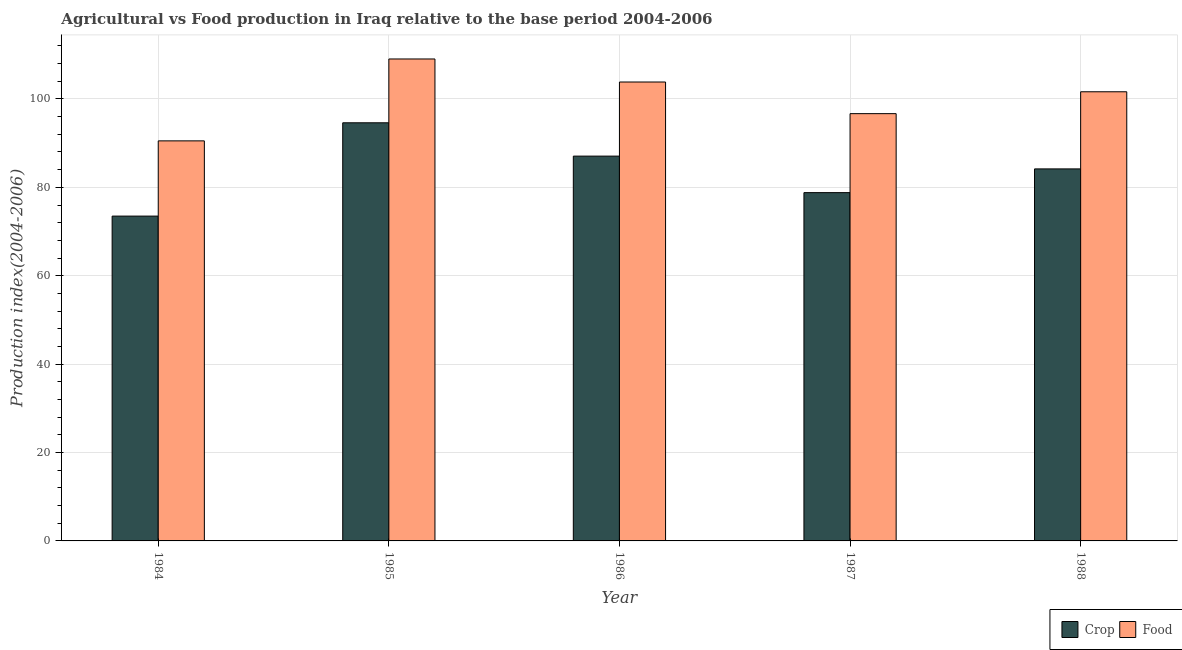How many different coloured bars are there?
Give a very brief answer. 2. How many bars are there on the 1st tick from the left?
Offer a terse response. 2. How many bars are there on the 3rd tick from the right?
Provide a succinct answer. 2. What is the label of the 3rd group of bars from the left?
Your response must be concise. 1986. In how many cases, is the number of bars for a given year not equal to the number of legend labels?
Give a very brief answer. 0. What is the food production index in 1985?
Make the answer very short. 109.04. Across all years, what is the maximum food production index?
Make the answer very short. 109.04. Across all years, what is the minimum food production index?
Make the answer very short. 90.51. In which year was the crop production index maximum?
Give a very brief answer. 1985. In which year was the food production index minimum?
Provide a succinct answer. 1984. What is the total food production index in the graph?
Provide a short and direct response. 501.67. What is the difference between the crop production index in 1984 and that in 1985?
Offer a terse response. -21.11. What is the difference between the crop production index in 1988 and the food production index in 1984?
Keep it short and to the point. 10.68. What is the average food production index per year?
Give a very brief answer. 100.33. In how many years, is the crop production index greater than 56?
Keep it short and to the point. 5. What is the ratio of the food production index in 1987 to that in 1988?
Offer a terse response. 0.95. Is the difference between the crop production index in 1985 and 1986 greater than the difference between the food production index in 1985 and 1986?
Your response must be concise. No. What is the difference between the highest and the second highest food production index?
Make the answer very short. 5.21. What is the difference between the highest and the lowest crop production index?
Offer a very short reply. 21.11. Is the sum of the food production index in 1986 and 1987 greater than the maximum crop production index across all years?
Give a very brief answer. Yes. What does the 2nd bar from the left in 1986 represents?
Give a very brief answer. Food. What does the 2nd bar from the right in 1984 represents?
Give a very brief answer. Crop. Are all the bars in the graph horizontal?
Your response must be concise. No. How many years are there in the graph?
Provide a succinct answer. 5. Does the graph contain grids?
Make the answer very short. Yes. How many legend labels are there?
Offer a terse response. 2. What is the title of the graph?
Offer a terse response. Agricultural vs Food production in Iraq relative to the base period 2004-2006. What is the label or title of the X-axis?
Your response must be concise. Year. What is the label or title of the Y-axis?
Give a very brief answer. Production index(2004-2006). What is the Production index(2004-2006) in Crop in 1984?
Keep it short and to the point. 73.49. What is the Production index(2004-2006) in Food in 1984?
Provide a succinct answer. 90.51. What is the Production index(2004-2006) of Crop in 1985?
Provide a succinct answer. 94.6. What is the Production index(2004-2006) in Food in 1985?
Give a very brief answer. 109.04. What is the Production index(2004-2006) of Crop in 1986?
Offer a very short reply. 87.06. What is the Production index(2004-2006) of Food in 1986?
Make the answer very short. 103.83. What is the Production index(2004-2006) in Crop in 1987?
Keep it short and to the point. 78.8. What is the Production index(2004-2006) in Food in 1987?
Your answer should be compact. 96.67. What is the Production index(2004-2006) of Crop in 1988?
Your response must be concise. 84.17. What is the Production index(2004-2006) of Food in 1988?
Provide a short and direct response. 101.62. Across all years, what is the maximum Production index(2004-2006) in Crop?
Offer a terse response. 94.6. Across all years, what is the maximum Production index(2004-2006) in Food?
Make the answer very short. 109.04. Across all years, what is the minimum Production index(2004-2006) of Crop?
Give a very brief answer. 73.49. Across all years, what is the minimum Production index(2004-2006) in Food?
Your response must be concise. 90.51. What is the total Production index(2004-2006) in Crop in the graph?
Your response must be concise. 418.12. What is the total Production index(2004-2006) of Food in the graph?
Give a very brief answer. 501.67. What is the difference between the Production index(2004-2006) of Crop in 1984 and that in 1985?
Make the answer very short. -21.11. What is the difference between the Production index(2004-2006) in Food in 1984 and that in 1985?
Keep it short and to the point. -18.53. What is the difference between the Production index(2004-2006) in Crop in 1984 and that in 1986?
Your answer should be compact. -13.57. What is the difference between the Production index(2004-2006) in Food in 1984 and that in 1986?
Offer a very short reply. -13.32. What is the difference between the Production index(2004-2006) in Crop in 1984 and that in 1987?
Ensure brevity in your answer.  -5.31. What is the difference between the Production index(2004-2006) in Food in 1984 and that in 1987?
Offer a terse response. -6.16. What is the difference between the Production index(2004-2006) of Crop in 1984 and that in 1988?
Ensure brevity in your answer.  -10.68. What is the difference between the Production index(2004-2006) of Food in 1984 and that in 1988?
Give a very brief answer. -11.11. What is the difference between the Production index(2004-2006) in Crop in 1985 and that in 1986?
Keep it short and to the point. 7.54. What is the difference between the Production index(2004-2006) of Food in 1985 and that in 1986?
Your response must be concise. 5.21. What is the difference between the Production index(2004-2006) of Crop in 1985 and that in 1987?
Offer a terse response. 15.8. What is the difference between the Production index(2004-2006) in Food in 1985 and that in 1987?
Ensure brevity in your answer.  12.37. What is the difference between the Production index(2004-2006) of Crop in 1985 and that in 1988?
Make the answer very short. 10.43. What is the difference between the Production index(2004-2006) of Food in 1985 and that in 1988?
Make the answer very short. 7.42. What is the difference between the Production index(2004-2006) of Crop in 1986 and that in 1987?
Give a very brief answer. 8.26. What is the difference between the Production index(2004-2006) in Food in 1986 and that in 1987?
Your answer should be compact. 7.16. What is the difference between the Production index(2004-2006) in Crop in 1986 and that in 1988?
Your answer should be very brief. 2.89. What is the difference between the Production index(2004-2006) in Food in 1986 and that in 1988?
Give a very brief answer. 2.21. What is the difference between the Production index(2004-2006) in Crop in 1987 and that in 1988?
Ensure brevity in your answer.  -5.37. What is the difference between the Production index(2004-2006) in Food in 1987 and that in 1988?
Give a very brief answer. -4.95. What is the difference between the Production index(2004-2006) of Crop in 1984 and the Production index(2004-2006) of Food in 1985?
Offer a terse response. -35.55. What is the difference between the Production index(2004-2006) in Crop in 1984 and the Production index(2004-2006) in Food in 1986?
Make the answer very short. -30.34. What is the difference between the Production index(2004-2006) of Crop in 1984 and the Production index(2004-2006) of Food in 1987?
Offer a very short reply. -23.18. What is the difference between the Production index(2004-2006) in Crop in 1984 and the Production index(2004-2006) in Food in 1988?
Make the answer very short. -28.13. What is the difference between the Production index(2004-2006) of Crop in 1985 and the Production index(2004-2006) of Food in 1986?
Give a very brief answer. -9.23. What is the difference between the Production index(2004-2006) of Crop in 1985 and the Production index(2004-2006) of Food in 1987?
Offer a terse response. -2.07. What is the difference between the Production index(2004-2006) in Crop in 1985 and the Production index(2004-2006) in Food in 1988?
Provide a succinct answer. -7.02. What is the difference between the Production index(2004-2006) in Crop in 1986 and the Production index(2004-2006) in Food in 1987?
Offer a very short reply. -9.61. What is the difference between the Production index(2004-2006) of Crop in 1986 and the Production index(2004-2006) of Food in 1988?
Keep it short and to the point. -14.56. What is the difference between the Production index(2004-2006) of Crop in 1987 and the Production index(2004-2006) of Food in 1988?
Your answer should be very brief. -22.82. What is the average Production index(2004-2006) of Crop per year?
Offer a terse response. 83.62. What is the average Production index(2004-2006) in Food per year?
Your answer should be compact. 100.33. In the year 1984, what is the difference between the Production index(2004-2006) of Crop and Production index(2004-2006) of Food?
Keep it short and to the point. -17.02. In the year 1985, what is the difference between the Production index(2004-2006) of Crop and Production index(2004-2006) of Food?
Offer a terse response. -14.44. In the year 1986, what is the difference between the Production index(2004-2006) in Crop and Production index(2004-2006) in Food?
Keep it short and to the point. -16.77. In the year 1987, what is the difference between the Production index(2004-2006) of Crop and Production index(2004-2006) of Food?
Make the answer very short. -17.87. In the year 1988, what is the difference between the Production index(2004-2006) in Crop and Production index(2004-2006) in Food?
Keep it short and to the point. -17.45. What is the ratio of the Production index(2004-2006) in Crop in 1984 to that in 1985?
Provide a short and direct response. 0.78. What is the ratio of the Production index(2004-2006) of Food in 1984 to that in 1985?
Your answer should be compact. 0.83. What is the ratio of the Production index(2004-2006) in Crop in 1984 to that in 1986?
Provide a short and direct response. 0.84. What is the ratio of the Production index(2004-2006) in Food in 1984 to that in 1986?
Ensure brevity in your answer.  0.87. What is the ratio of the Production index(2004-2006) in Crop in 1984 to that in 1987?
Offer a terse response. 0.93. What is the ratio of the Production index(2004-2006) of Food in 1984 to that in 1987?
Your response must be concise. 0.94. What is the ratio of the Production index(2004-2006) of Crop in 1984 to that in 1988?
Offer a terse response. 0.87. What is the ratio of the Production index(2004-2006) of Food in 1984 to that in 1988?
Make the answer very short. 0.89. What is the ratio of the Production index(2004-2006) in Crop in 1985 to that in 1986?
Offer a terse response. 1.09. What is the ratio of the Production index(2004-2006) in Food in 1985 to that in 1986?
Your answer should be very brief. 1.05. What is the ratio of the Production index(2004-2006) in Crop in 1985 to that in 1987?
Provide a short and direct response. 1.2. What is the ratio of the Production index(2004-2006) of Food in 1985 to that in 1987?
Your response must be concise. 1.13. What is the ratio of the Production index(2004-2006) in Crop in 1985 to that in 1988?
Your answer should be very brief. 1.12. What is the ratio of the Production index(2004-2006) in Food in 1985 to that in 1988?
Your answer should be compact. 1.07. What is the ratio of the Production index(2004-2006) of Crop in 1986 to that in 1987?
Make the answer very short. 1.1. What is the ratio of the Production index(2004-2006) in Food in 1986 to that in 1987?
Make the answer very short. 1.07. What is the ratio of the Production index(2004-2006) in Crop in 1986 to that in 1988?
Your answer should be compact. 1.03. What is the ratio of the Production index(2004-2006) of Food in 1986 to that in 1988?
Your answer should be compact. 1.02. What is the ratio of the Production index(2004-2006) in Crop in 1987 to that in 1988?
Offer a terse response. 0.94. What is the ratio of the Production index(2004-2006) in Food in 1987 to that in 1988?
Give a very brief answer. 0.95. What is the difference between the highest and the second highest Production index(2004-2006) in Crop?
Offer a very short reply. 7.54. What is the difference between the highest and the second highest Production index(2004-2006) in Food?
Keep it short and to the point. 5.21. What is the difference between the highest and the lowest Production index(2004-2006) in Crop?
Provide a succinct answer. 21.11. What is the difference between the highest and the lowest Production index(2004-2006) in Food?
Your response must be concise. 18.53. 